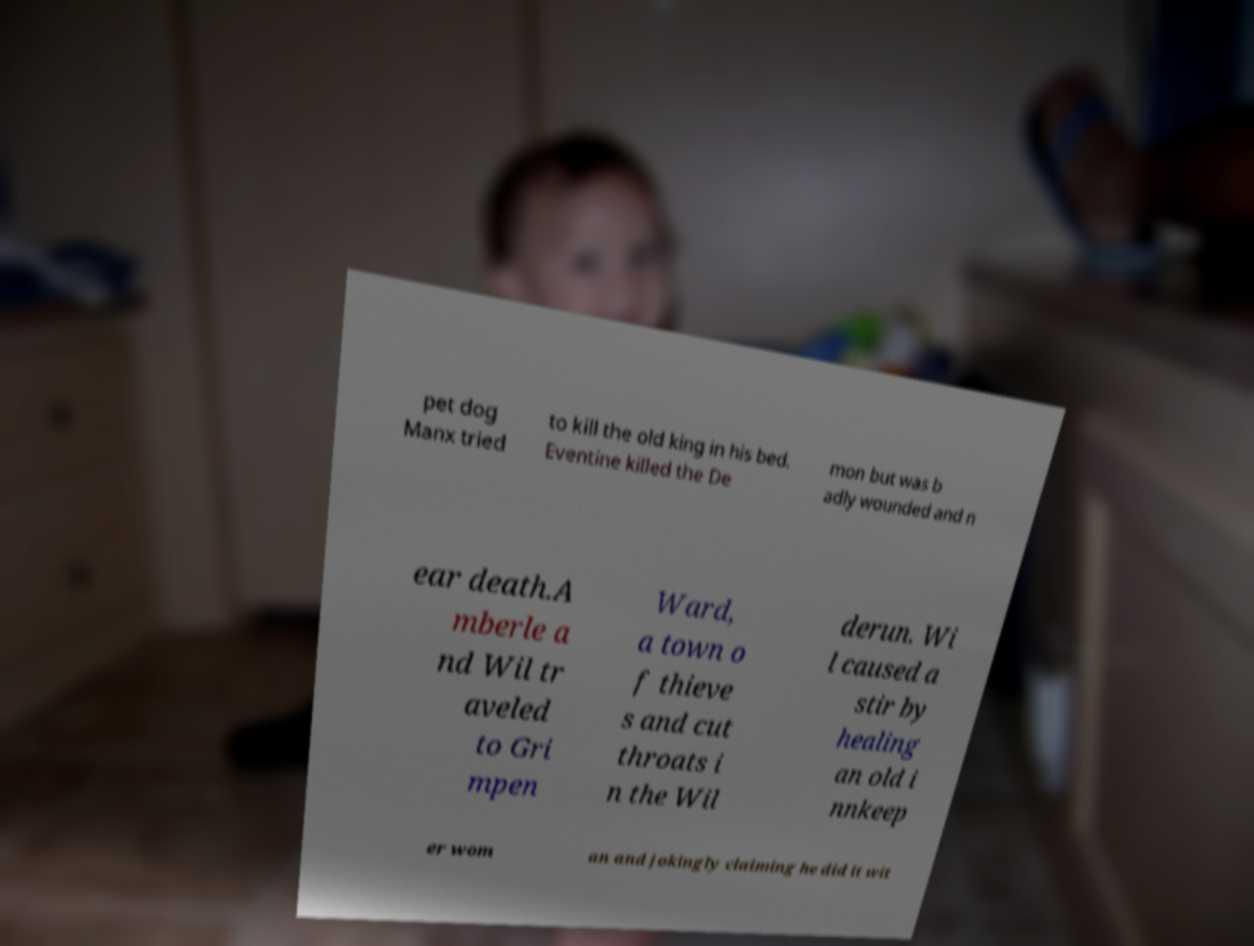Please identify and transcribe the text found in this image. pet dog Manx tried to kill the old king in his bed. Eventine killed the De mon but was b adly wounded and n ear death.A mberle a nd Wil tr aveled to Gri mpen Ward, a town o f thieve s and cut throats i n the Wil derun. Wi l caused a stir by healing an old i nnkeep er wom an and jokingly claiming he did it wit 